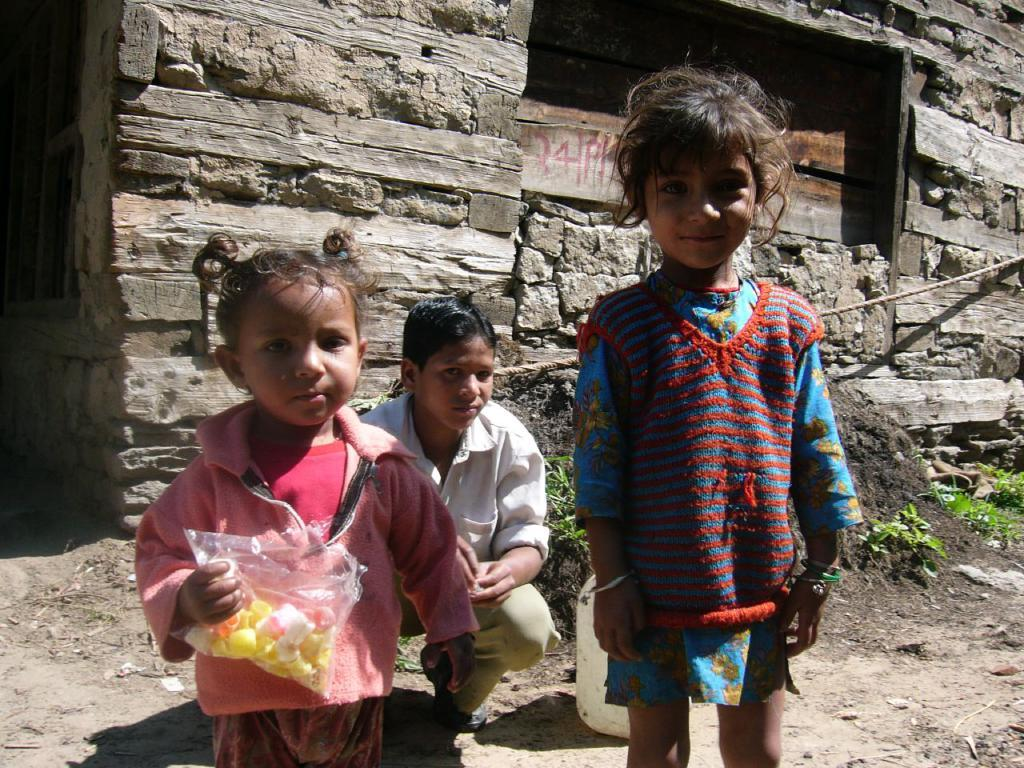What is the main subject of the image? The main subject of the image is a group of children. What are the children doing in the image? The children are standing on the ground and smiling. What can be seen in the background of the image? There is a wall and a window in the image. Are there any plants visible in the image? Yes, there are small plants in the image. What type of wish does the uncle grant to the children in the image? There is no uncle present in the image, and therefore no such interaction can be observed. 